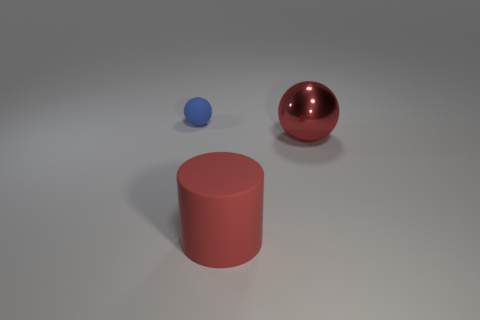Add 2 shiny spheres. How many objects exist? 5 Subtract 2 balls. How many balls are left? 0 Subtract all blue spheres. How many spheres are left? 1 Subtract 0 yellow balls. How many objects are left? 3 Subtract all cylinders. How many objects are left? 2 Subtract all yellow balls. Subtract all green cylinders. How many balls are left? 2 Subtract all brown cylinders. How many blue balls are left? 1 Subtract all small balls. Subtract all large matte cylinders. How many objects are left? 1 Add 2 big shiny things. How many big shiny things are left? 3 Add 3 balls. How many balls exist? 5 